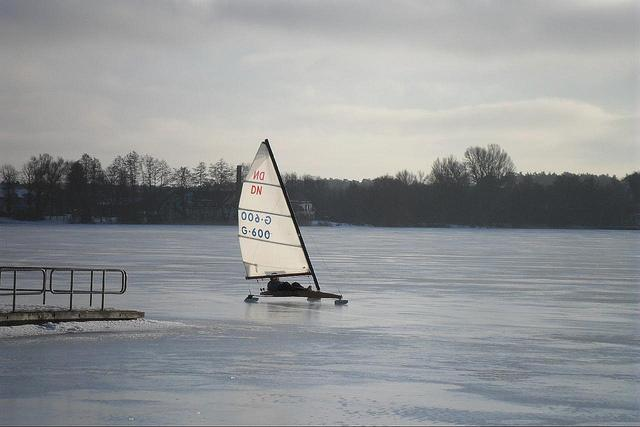In which manner does this vehicle move?

Choices:
A) flying
B) drilling
C) rolling
D) sliding sliding 